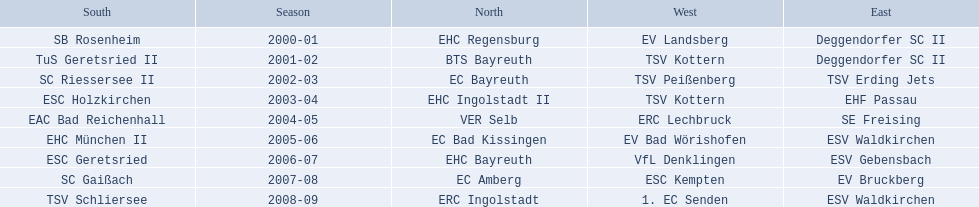Which teams have won in the bavarian ice hockey leagues between 2000 and 2009? EHC Regensburg, SB Rosenheim, Deggendorfer SC II, EV Landsberg, BTS Bayreuth, TuS Geretsried II, TSV Kottern, EC Bayreuth, SC Riessersee II, TSV Erding Jets, TSV Peißenberg, EHC Ingolstadt II, ESC Holzkirchen, EHF Passau, TSV Kottern, VER Selb, EAC Bad Reichenhall, SE Freising, ERC Lechbruck, EC Bad Kissingen, EHC München II, ESV Waldkirchen, EV Bad Wörishofen, EHC Bayreuth, ESC Geretsried, ESV Gebensbach, VfL Denklingen, EC Amberg, SC Gaißach, EV Bruckberg, ESC Kempten, ERC Ingolstadt, TSV Schliersee, ESV Waldkirchen, 1. EC Senden. Which of these winning teams have won the north? EHC Regensburg, BTS Bayreuth, EC Bayreuth, EHC Ingolstadt II, VER Selb, EC Bad Kissingen, EHC Bayreuth, EC Amberg, ERC Ingolstadt. Which of the teams that won the north won in the 2000/2001 season? EHC Regensburg. 